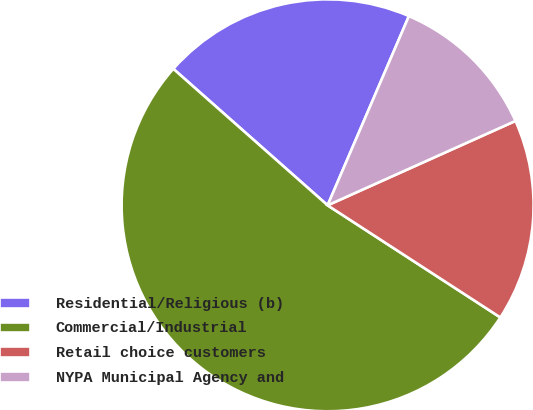<chart> <loc_0><loc_0><loc_500><loc_500><pie_chart><fcel>Residential/Religious (b)<fcel>Commercial/Industrial<fcel>Retail choice customers<fcel>NYPA Municipal Agency and<nl><fcel>19.93%<fcel>52.36%<fcel>15.88%<fcel>11.82%<nl></chart> 